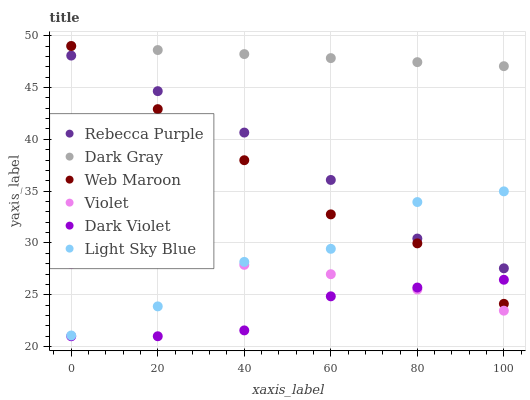Does Dark Violet have the minimum area under the curve?
Answer yes or no. Yes. Does Dark Gray have the maximum area under the curve?
Answer yes or no. Yes. Does Dark Gray have the minimum area under the curve?
Answer yes or no. No. Does Dark Violet have the maximum area under the curve?
Answer yes or no. No. Is Dark Gray the smoothest?
Answer yes or no. Yes. Is Light Sky Blue the roughest?
Answer yes or no. Yes. Is Dark Violet the smoothest?
Answer yes or no. No. Is Dark Violet the roughest?
Answer yes or no. No. Does Dark Violet have the lowest value?
Answer yes or no. Yes. Does Dark Gray have the lowest value?
Answer yes or no. No. Does Dark Gray have the highest value?
Answer yes or no. Yes. Does Dark Violet have the highest value?
Answer yes or no. No. Is Dark Violet less than Light Sky Blue?
Answer yes or no. Yes. Is Light Sky Blue greater than Dark Violet?
Answer yes or no. Yes. Does Web Maroon intersect Rebecca Purple?
Answer yes or no. Yes. Is Web Maroon less than Rebecca Purple?
Answer yes or no. No. Is Web Maroon greater than Rebecca Purple?
Answer yes or no. No. Does Dark Violet intersect Light Sky Blue?
Answer yes or no. No. 